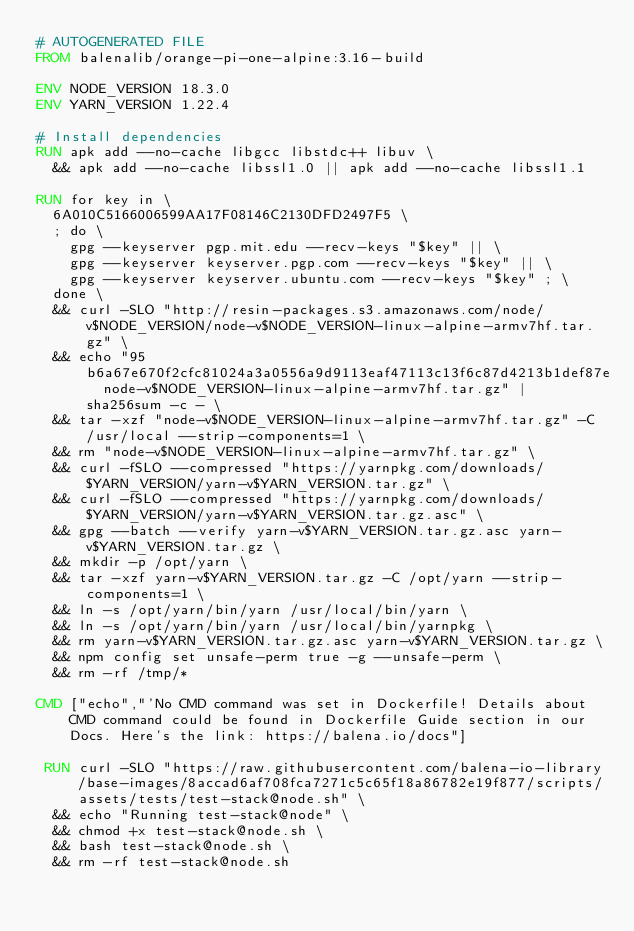Convert code to text. <code><loc_0><loc_0><loc_500><loc_500><_Dockerfile_># AUTOGENERATED FILE
FROM balenalib/orange-pi-one-alpine:3.16-build

ENV NODE_VERSION 18.3.0
ENV YARN_VERSION 1.22.4

# Install dependencies
RUN apk add --no-cache libgcc libstdc++ libuv \
	&& apk add --no-cache libssl1.0 || apk add --no-cache libssl1.1

RUN for key in \
	6A010C5166006599AA17F08146C2130DFD2497F5 \
	; do \
		gpg --keyserver pgp.mit.edu --recv-keys "$key" || \
		gpg --keyserver keyserver.pgp.com --recv-keys "$key" || \
		gpg --keyserver keyserver.ubuntu.com --recv-keys "$key" ; \
	done \
	&& curl -SLO "http://resin-packages.s3.amazonaws.com/node/v$NODE_VERSION/node-v$NODE_VERSION-linux-alpine-armv7hf.tar.gz" \
	&& echo "95b6a67e670f2cfc81024a3a0556a9d9113eaf47113c13f6c87d4213b1def87e  node-v$NODE_VERSION-linux-alpine-armv7hf.tar.gz" | sha256sum -c - \
	&& tar -xzf "node-v$NODE_VERSION-linux-alpine-armv7hf.tar.gz" -C /usr/local --strip-components=1 \
	&& rm "node-v$NODE_VERSION-linux-alpine-armv7hf.tar.gz" \
	&& curl -fSLO --compressed "https://yarnpkg.com/downloads/$YARN_VERSION/yarn-v$YARN_VERSION.tar.gz" \
	&& curl -fSLO --compressed "https://yarnpkg.com/downloads/$YARN_VERSION/yarn-v$YARN_VERSION.tar.gz.asc" \
	&& gpg --batch --verify yarn-v$YARN_VERSION.tar.gz.asc yarn-v$YARN_VERSION.tar.gz \
	&& mkdir -p /opt/yarn \
	&& tar -xzf yarn-v$YARN_VERSION.tar.gz -C /opt/yarn --strip-components=1 \
	&& ln -s /opt/yarn/bin/yarn /usr/local/bin/yarn \
	&& ln -s /opt/yarn/bin/yarn /usr/local/bin/yarnpkg \
	&& rm yarn-v$YARN_VERSION.tar.gz.asc yarn-v$YARN_VERSION.tar.gz \
	&& npm config set unsafe-perm true -g --unsafe-perm \
	&& rm -rf /tmp/*

CMD ["echo","'No CMD command was set in Dockerfile! Details about CMD command could be found in Dockerfile Guide section in our Docs. Here's the link: https://balena.io/docs"]

 RUN curl -SLO "https://raw.githubusercontent.com/balena-io-library/base-images/8accad6af708fca7271c5c65f18a86782e19f877/scripts/assets/tests/test-stack@node.sh" \
  && echo "Running test-stack@node" \
  && chmod +x test-stack@node.sh \
  && bash test-stack@node.sh \
  && rm -rf test-stack@node.sh 
</code> 